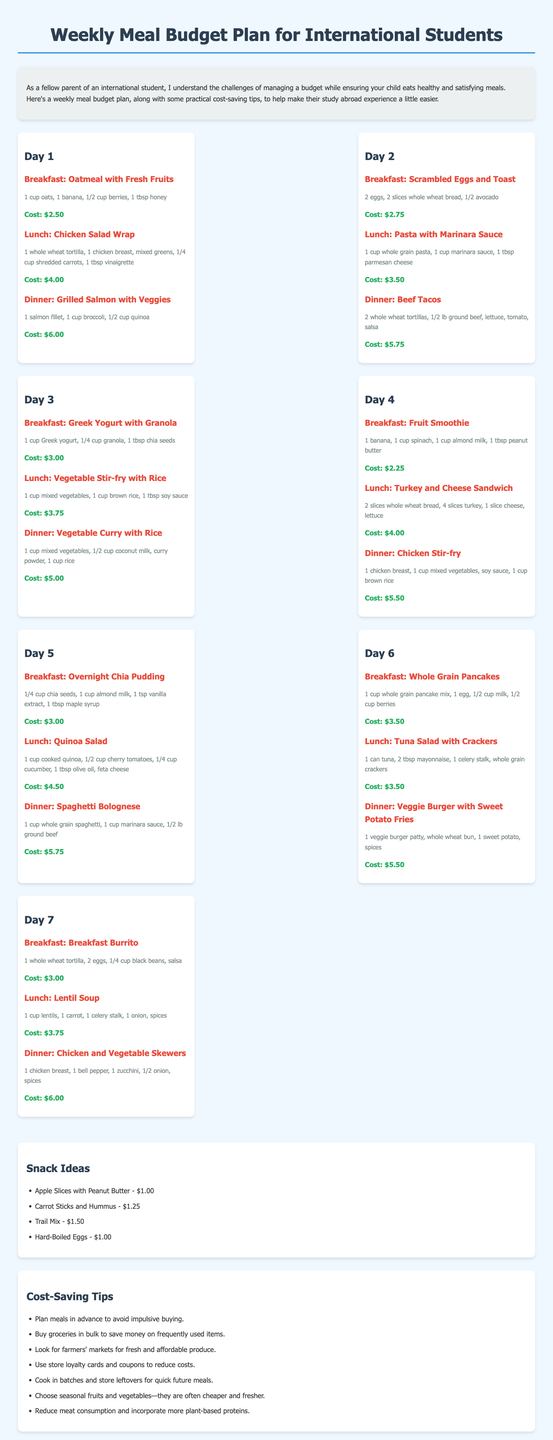What is the cost of a Chicken Salad Wrap? The cost of a Chicken Salad Wrap is listed under Day 1's lunch, which is $4.00.
Answer: $4.00 What ingredients are in the Fruit Smoothie? The ingredients for the Fruit Smoothie are detailed under Day 4's breakfast: 1 banana, 1 cup spinach, 1 cup almond milk, and 1 tbsp peanut butter.
Answer: 1 banana, 1 cup spinach, 1 cup almond milk, 1 tbsp peanut butter Which day features a Vegetable Stir-fry with Rice for lunch? The Vegetable Stir-fry with Rice is highlighted as lunch on Day 3.
Answer: Day 3 What is the total cost for Day 5 meals? The total cost for Day 5 meals is calculated by summing the costs of each meal on that day: $3.00 + $4.50 + $5.75 = $13.25.
Answer: $13.25 What are two snack ideas listed? The snack ideas are presented in the Snacks section, specifically mentioning Apple Slices with Peanut Butter and Carrot Sticks and Hummus.
Answer: Apple Slices with Peanut Butter, Carrot Sticks and Hummus What cost-saving tip suggests reducing meat consumption? The cost-saving tip that advises incorporating more plant-based proteins suggests reducing meat consumption.
Answer: Reduce meat consumption How many eggs are needed for the Scrambled Eggs and Toast? The recipe states that 2 eggs are needed for Scrambled Eggs and Toast, found under Day 2's breakfast.
Answer: 2 eggs What is the category of the section that includes Hard-Boiled Eggs? The Hard-Boiled Eggs are listed under the Snacks section, which suggests snack ideas.
Answer: Snacks 